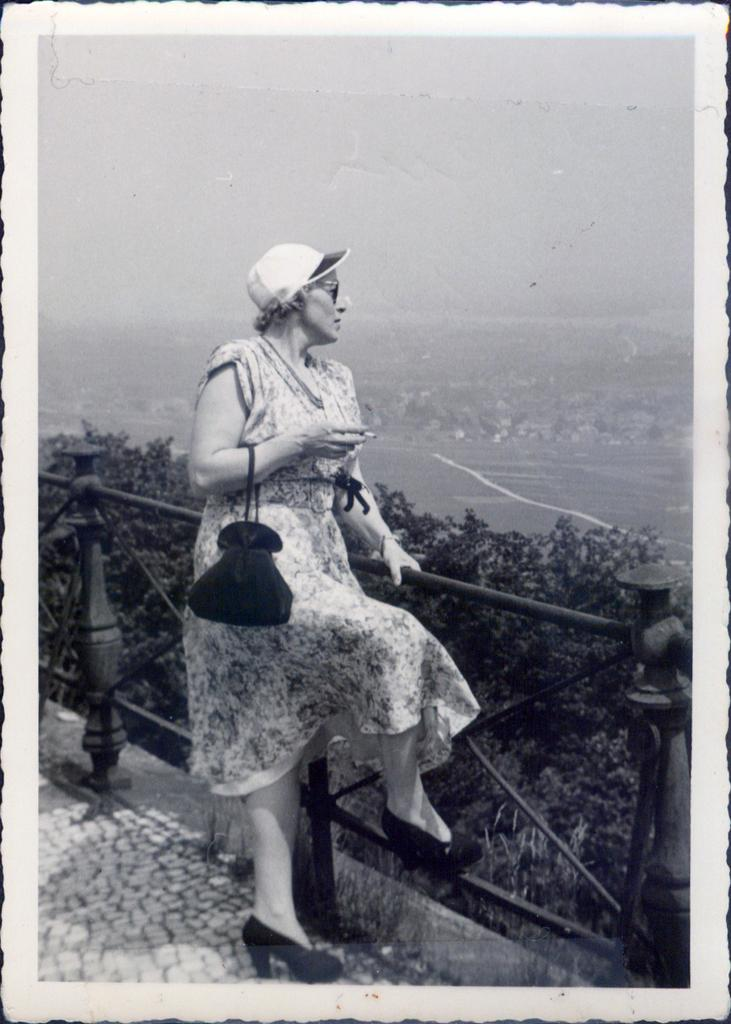What is the main subject of the image? There is a woman standing in the image. What is the woman wearing on her head? The woman is wearing a cap. What type of vegetation can be seen in the image? There are trees in the image. How is the image presented in terms of color? The background of the image is in black and white. What type of wheel can be seen in the image? There is no wheel present in the image. What is the caption of the image? The image does not have a caption, as we are only looking at the image and not any accompanying text. 